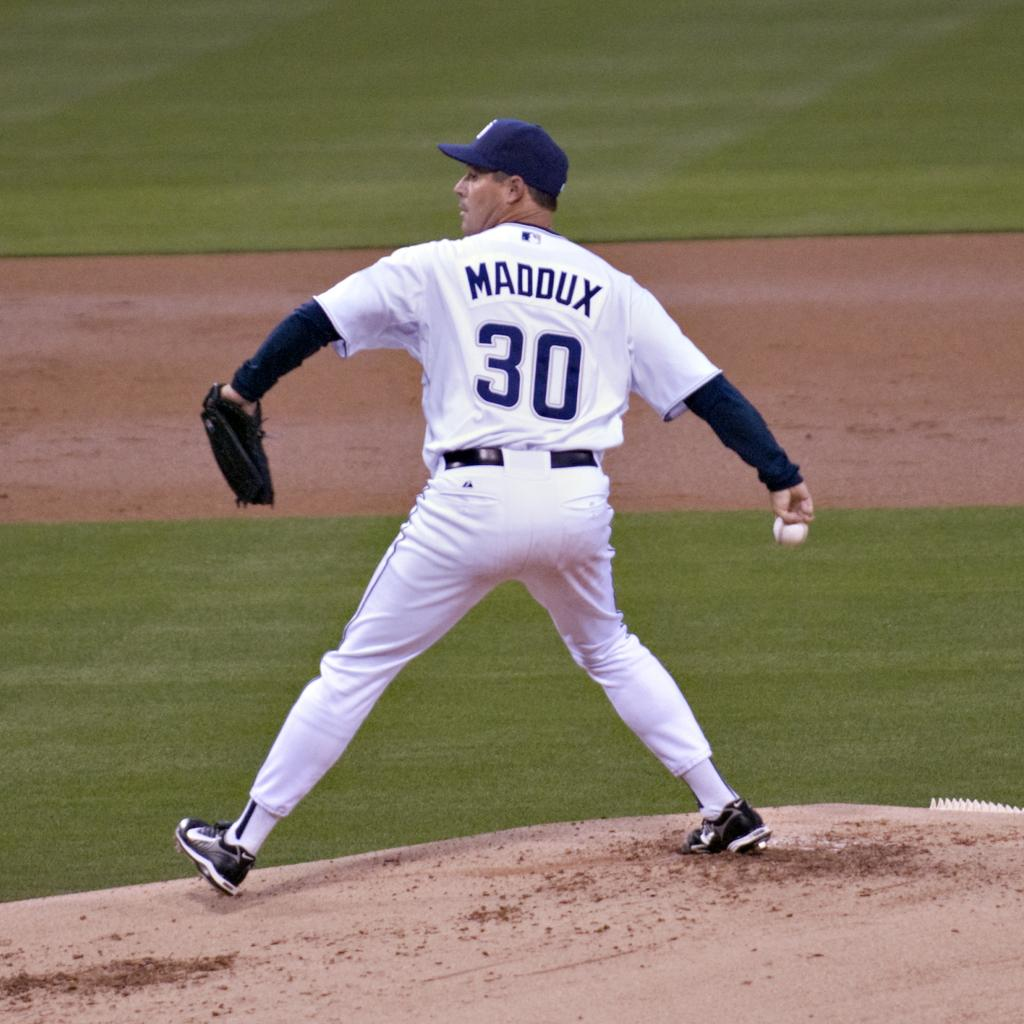<image>
Share a concise interpretation of the image provided. A baseball pitcher throwing a ball while wearing his team jersey with MADDUX on the back. 